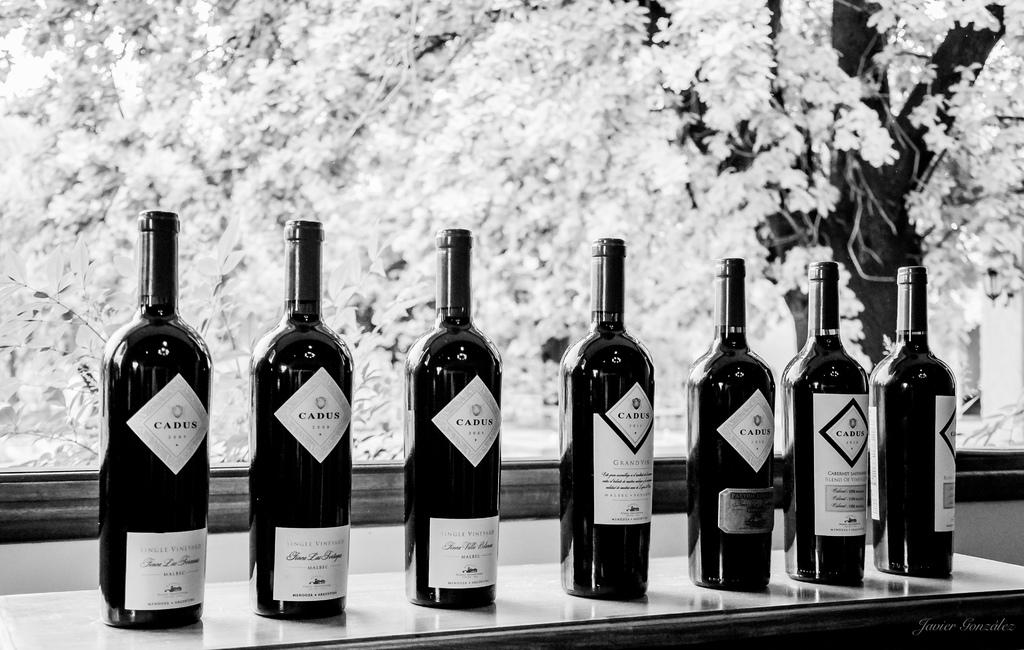<image>
Provide a brief description of the given image. Seven unopened bottles of Cadus wine sit on a counter. 